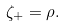Convert formula to latex. <formula><loc_0><loc_0><loc_500><loc_500>\zeta _ { + } = \rho .</formula> 